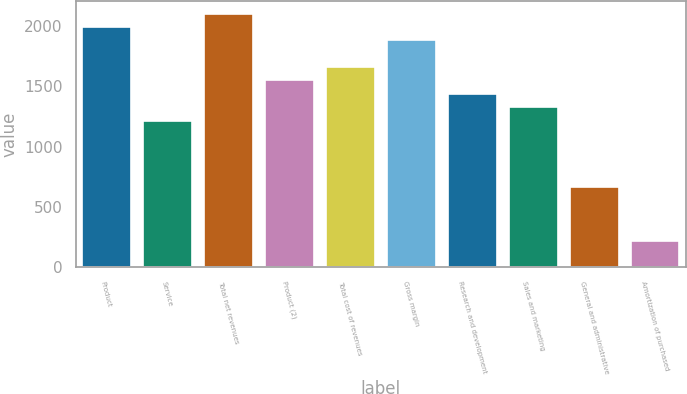<chart> <loc_0><loc_0><loc_500><loc_500><bar_chart><fcel>Product<fcel>Service<fcel>Total net revenues<fcel>Product (2)<fcel>Total cost of revenues<fcel>Gross margin<fcel>Research and development<fcel>Sales and marketing<fcel>General and administrative<fcel>Amortization of purchased<nl><fcel>1990.24<fcel>1216.32<fcel>2100.8<fcel>1548<fcel>1658.56<fcel>1879.68<fcel>1437.44<fcel>1326.88<fcel>663.52<fcel>221.28<nl></chart> 